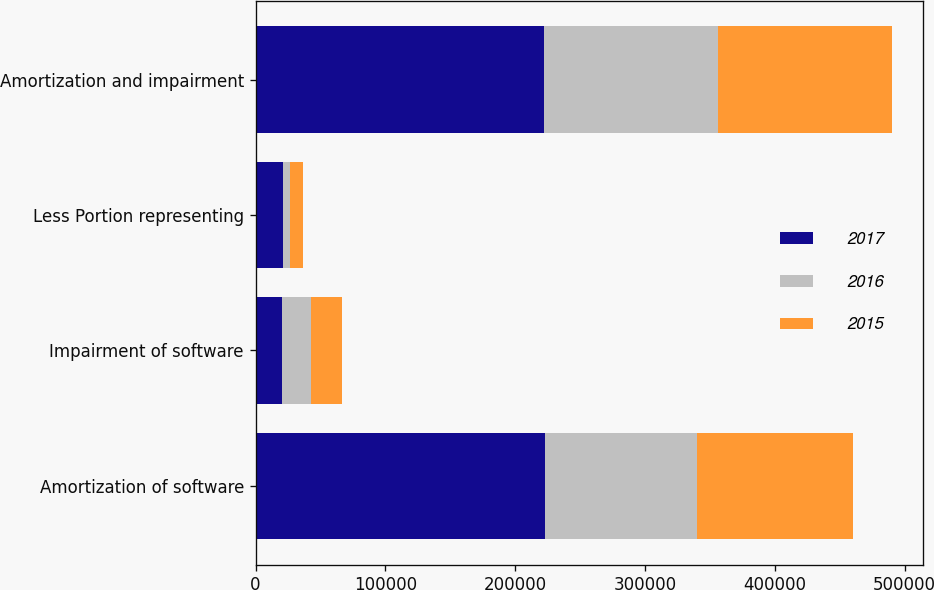Convert chart to OTSL. <chart><loc_0><loc_0><loc_500><loc_500><stacked_bar_chart><ecel><fcel>Amortization of software<fcel>Impairment of software<fcel>Less Portion representing<fcel>Amortization and impairment<nl><fcel>2017<fcel>222801<fcel>20166<fcel>21056<fcel>221911<nl><fcel>2016<fcel>117506<fcel>22671<fcel>5705<fcel>134472<nl><fcel>2015<fcel>119488<fcel>23947<fcel>9982<fcel>133453<nl></chart> 